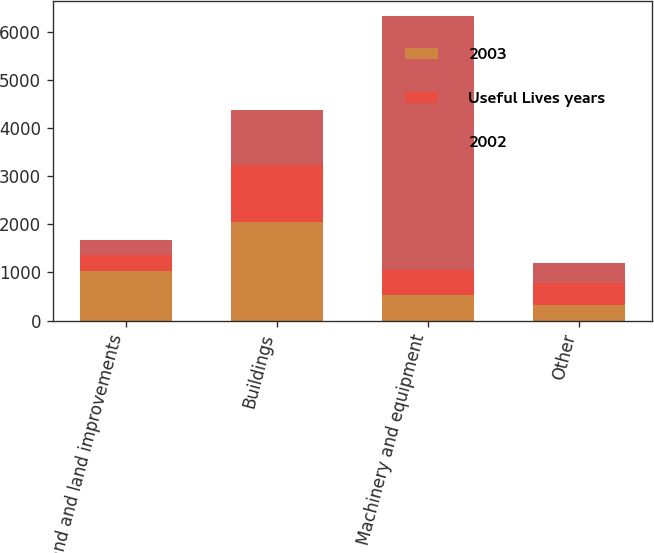<chart> <loc_0><loc_0><loc_500><loc_500><stacked_bar_chart><ecel><fcel>Land and land improvements<fcel>Buildings<fcel>Machinery and equipment<fcel>Other<nl><fcel>2003<fcel>1030<fcel>2050<fcel>525<fcel>320<nl><fcel>Useful Lives years<fcel>332<fcel>1189<fcel>525<fcel>453<nl><fcel>2002<fcel>309<fcel>1126<fcel>5273<fcel>419<nl></chart> 